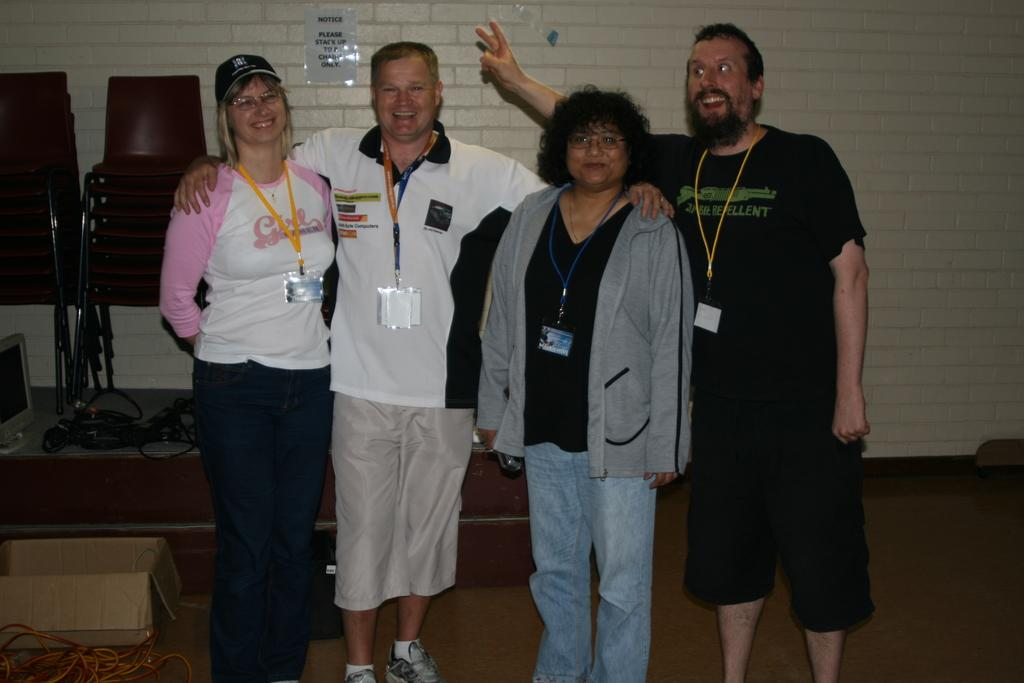How many people are in the image? There are four people in the image. What are the people doing in the image? The people are standing and smiling. What can be seen on the people's clothing? The people are wearing ID cards. What is visible in the background of the image? There is a wall, chairs, a monitor, cables, a cardboard box, and other things visible in the background. What is on the wall in the background? There is a poster on the wall. What type of thought can be seen floating above the people's heads in the image? There are no thoughts visible in the image; it only shows people standing, smiling, and wearing ID cards. How many apples are on the table in the image? There is no table or apples present in the image. 